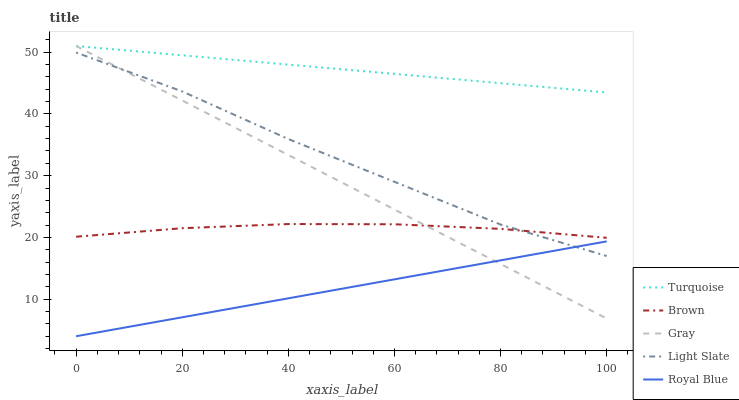Does Royal Blue have the minimum area under the curve?
Answer yes or no. Yes. Does Turquoise have the maximum area under the curve?
Answer yes or no. Yes. Does Brown have the minimum area under the curve?
Answer yes or no. No. Does Brown have the maximum area under the curve?
Answer yes or no. No. Is Royal Blue the smoothest?
Answer yes or no. Yes. Is Light Slate the roughest?
Answer yes or no. Yes. Is Brown the smoothest?
Answer yes or no. No. Is Brown the roughest?
Answer yes or no. No. Does Royal Blue have the lowest value?
Answer yes or no. Yes. Does Brown have the lowest value?
Answer yes or no. No. Does Gray have the highest value?
Answer yes or no. Yes. Does Brown have the highest value?
Answer yes or no. No. Is Royal Blue less than Turquoise?
Answer yes or no. Yes. Is Turquoise greater than Light Slate?
Answer yes or no. Yes. Does Turquoise intersect Gray?
Answer yes or no. Yes. Is Turquoise less than Gray?
Answer yes or no. No. Is Turquoise greater than Gray?
Answer yes or no. No. Does Royal Blue intersect Turquoise?
Answer yes or no. No. 